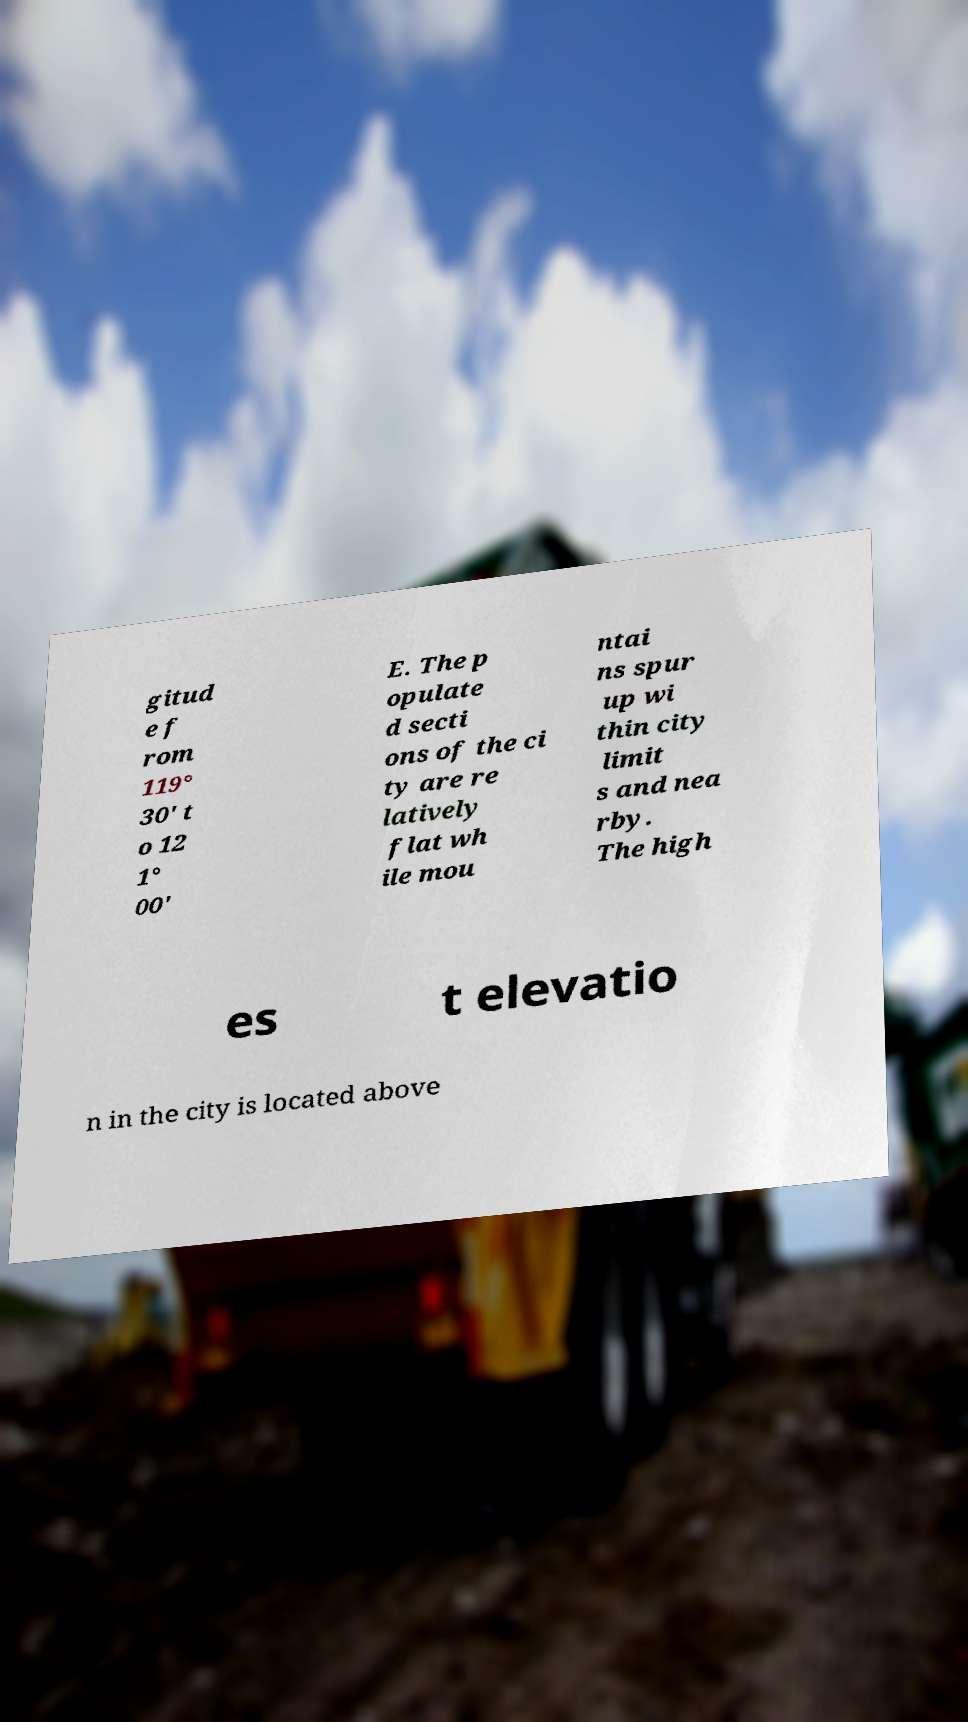Can you accurately transcribe the text from the provided image for me? gitud e f rom 119° 30' t o 12 1° 00' E. The p opulate d secti ons of the ci ty are re latively flat wh ile mou ntai ns spur up wi thin city limit s and nea rby. The high es t elevatio n in the city is located above 